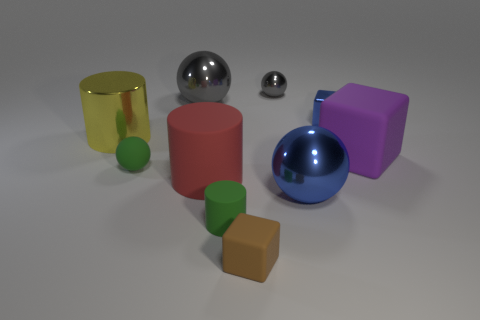There is a cylinder that is the same size as the green ball; what color is it?
Your response must be concise. Green. What number of objects are rubber cubes that are to the right of the brown matte object or blue objects?
Your answer should be very brief. 3. What number of other things are the same size as the purple thing?
Give a very brief answer. 4. Is the number of big blue metallic things right of the big purple cube the same as the number of large yellow metal cylinders that are to the left of the big yellow metallic object?
Your answer should be compact. Yes. There is another large metal thing that is the same shape as the large gray thing; what is its color?
Provide a short and direct response. Blue. Do the big sphere behind the big rubber block and the tiny metal ball have the same color?
Provide a short and direct response. Yes. What size is the yellow thing that is the same shape as the big red object?
Provide a short and direct response. Large. How many large blue things are the same material as the small gray thing?
Make the answer very short. 1. There is a large gray metallic object that is left of the large sphere that is in front of the big purple rubber block; are there any cylinders that are on the left side of it?
Your answer should be very brief. Yes. The big gray object has what shape?
Provide a succinct answer. Sphere. 